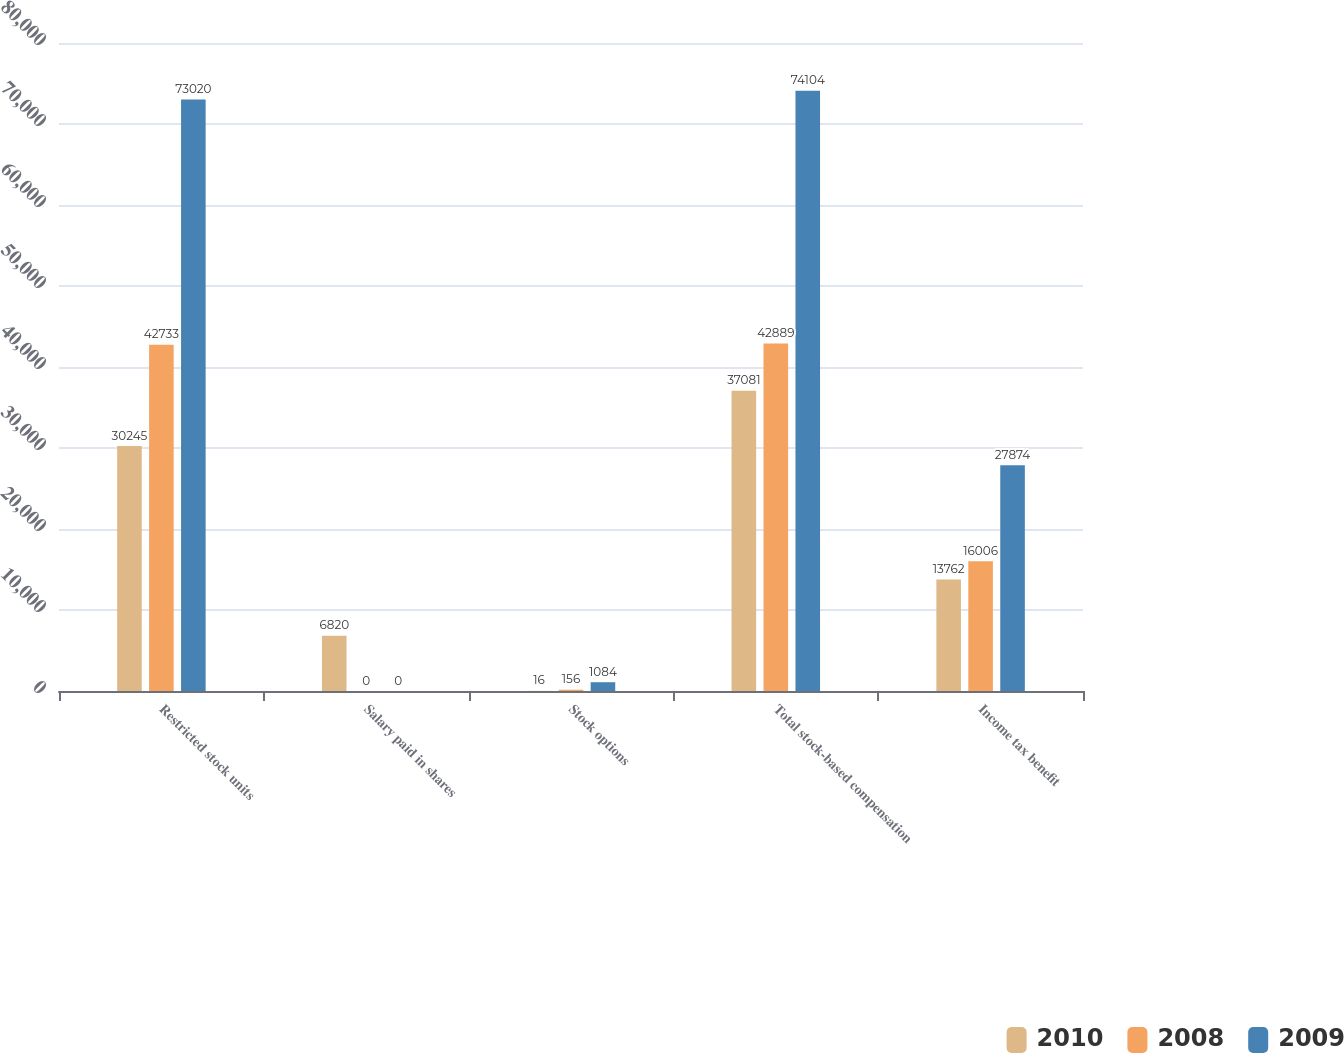<chart> <loc_0><loc_0><loc_500><loc_500><stacked_bar_chart><ecel><fcel>Restricted stock units<fcel>Salary paid in shares<fcel>Stock options<fcel>Total stock-based compensation<fcel>Income tax benefit<nl><fcel>2010<fcel>30245<fcel>6820<fcel>16<fcel>37081<fcel>13762<nl><fcel>2008<fcel>42733<fcel>0<fcel>156<fcel>42889<fcel>16006<nl><fcel>2009<fcel>73020<fcel>0<fcel>1084<fcel>74104<fcel>27874<nl></chart> 